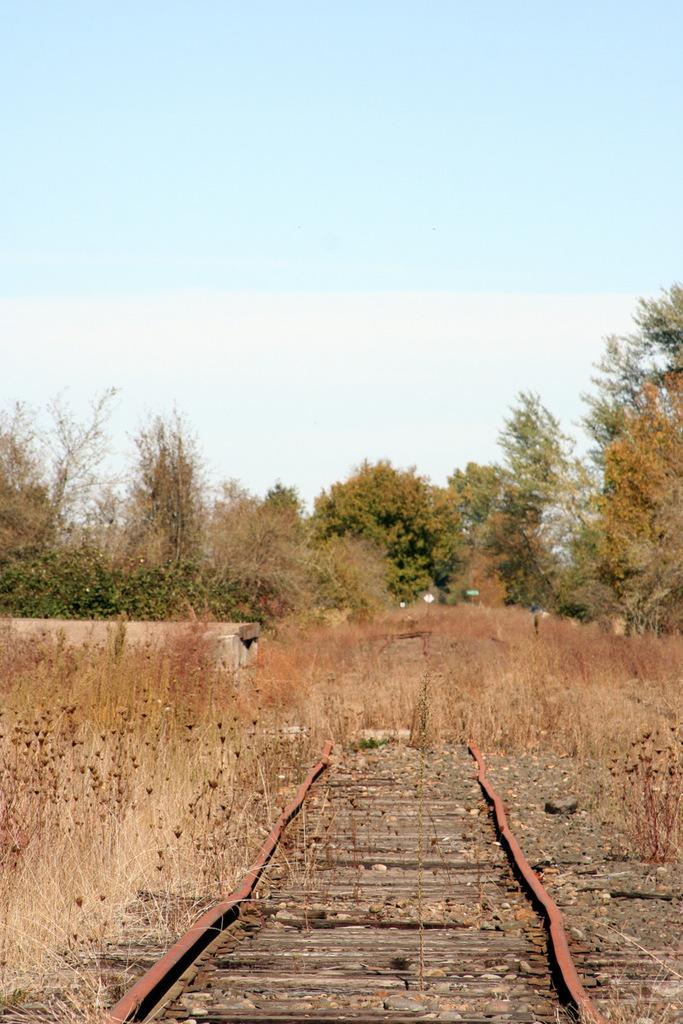What type of natural elements can be seen in the image? There are plants and trees in the image. What other objects can be seen in the image? There are stones, poles with boards, and a track in the image. What is visible in the background of the image? The sky is visible in the background of the image. What color is the pipe that is being used by the beginner in the image? There is no pipe or beginner present in the image. 